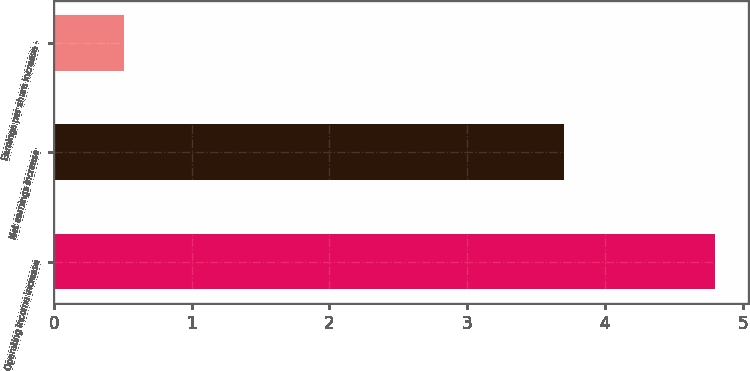<chart> <loc_0><loc_0><loc_500><loc_500><bar_chart><fcel>Operating income increase<fcel>Net earnings increase<fcel>Earnings per share increase -<nl><fcel>4.8<fcel>3.7<fcel>0.51<nl></chart> 